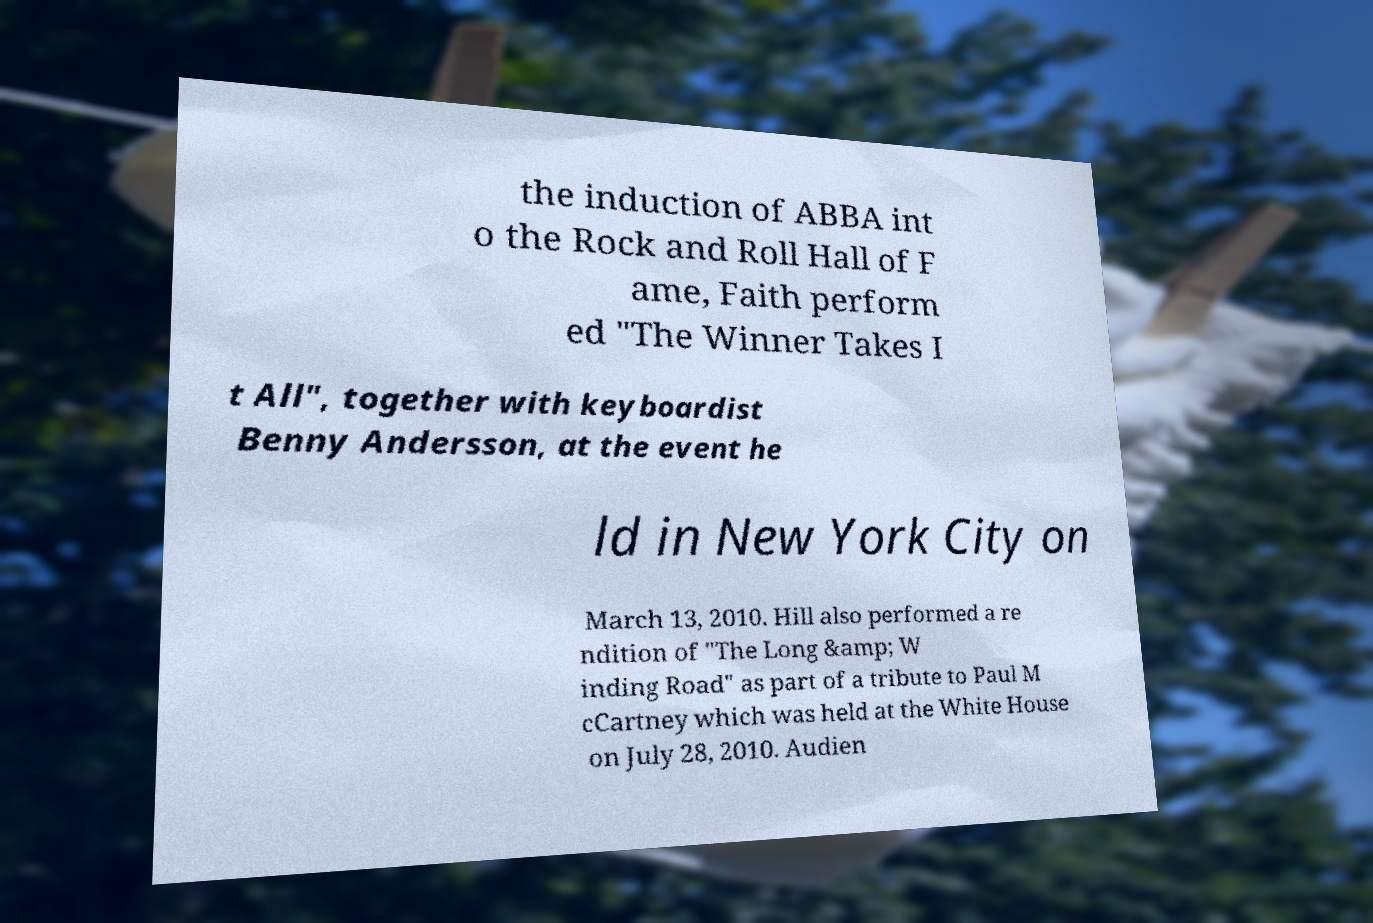What messages or text are displayed in this image? I need them in a readable, typed format. the induction of ABBA int o the Rock and Roll Hall of F ame, Faith perform ed "The Winner Takes I t All", together with keyboardist Benny Andersson, at the event he ld in New York City on March 13, 2010. Hill also performed a re ndition of "The Long &amp; W inding Road" as part of a tribute to Paul M cCartney which was held at the White House on July 28, 2010. Audien 